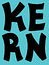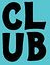What text appears in these images from left to right, separated by a semicolon? KERN; CLUB 